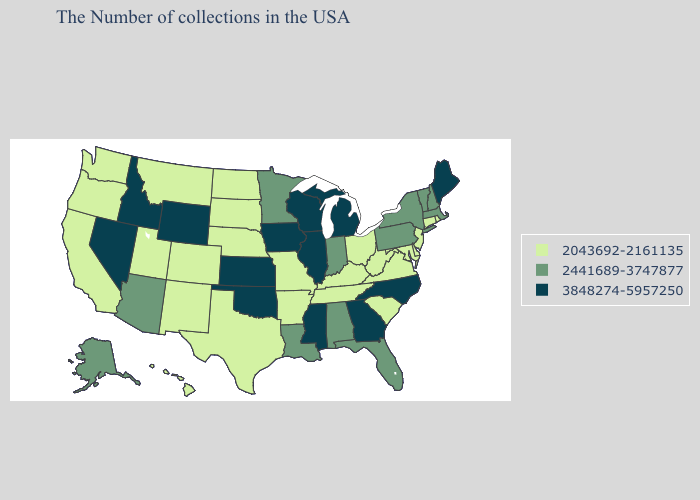Does Alaska have a lower value than Ohio?
Short answer required. No. Name the states that have a value in the range 2043692-2161135?
Be succinct. Rhode Island, Connecticut, New Jersey, Delaware, Maryland, Virginia, South Carolina, West Virginia, Ohio, Kentucky, Tennessee, Missouri, Arkansas, Nebraska, Texas, South Dakota, North Dakota, Colorado, New Mexico, Utah, Montana, California, Washington, Oregon, Hawaii. Among the states that border Oregon , does Nevada have the highest value?
Quick response, please. Yes. Which states have the highest value in the USA?
Quick response, please. Maine, North Carolina, Georgia, Michigan, Wisconsin, Illinois, Mississippi, Iowa, Kansas, Oklahoma, Wyoming, Idaho, Nevada. Does Nebraska have the highest value in the MidWest?
Give a very brief answer. No. What is the lowest value in the MidWest?
Keep it brief. 2043692-2161135. Does the map have missing data?
Answer briefly. No. How many symbols are there in the legend?
Give a very brief answer. 3. Is the legend a continuous bar?
Quick response, please. No. Does New York have the highest value in the Northeast?
Write a very short answer. No. Is the legend a continuous bar?
Be succinct. No. Among the states that border Louisiana , does Mississippi have the lowest value?
Be succinct. No. Does Connecticut have the lowest value in the Northeast?
Concise answer only. Yes. Does the map have missing data?
Answer briefly. No. Name the states that have a value in the range 3848274-5957250?
Give a very brief answer. Maine, North Carolina, Georgia, Michigan, Wisconsin, Illinois, Mississippi, Iowa, Kansas, Oklahoma, Wyoming, Idaho, Nevada. 